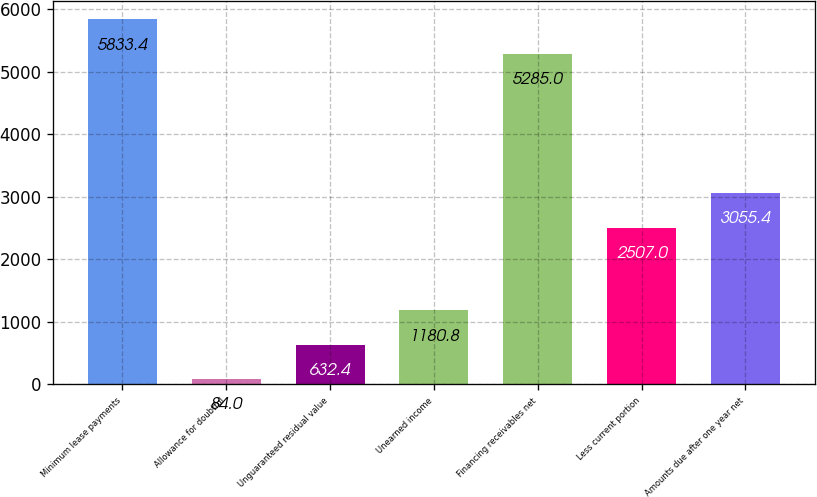<chart> <loc_0><loc_0><loc_500><loc_500><bar_chart><fcel>Minimum lease payments<fcel>Allowance for doubtful<fcel>Unguaranteed residual value<fcel>Unearned income<fcel>Financing receivables net<fcel>Less current portion<fcel>Amounts due after one year net<nl><fcel>5833.4<fcel>84<fcel>632.4<fcel>1180.8<fcel>5285<fcel>2507<fcel>3055.4<nl></chart> 